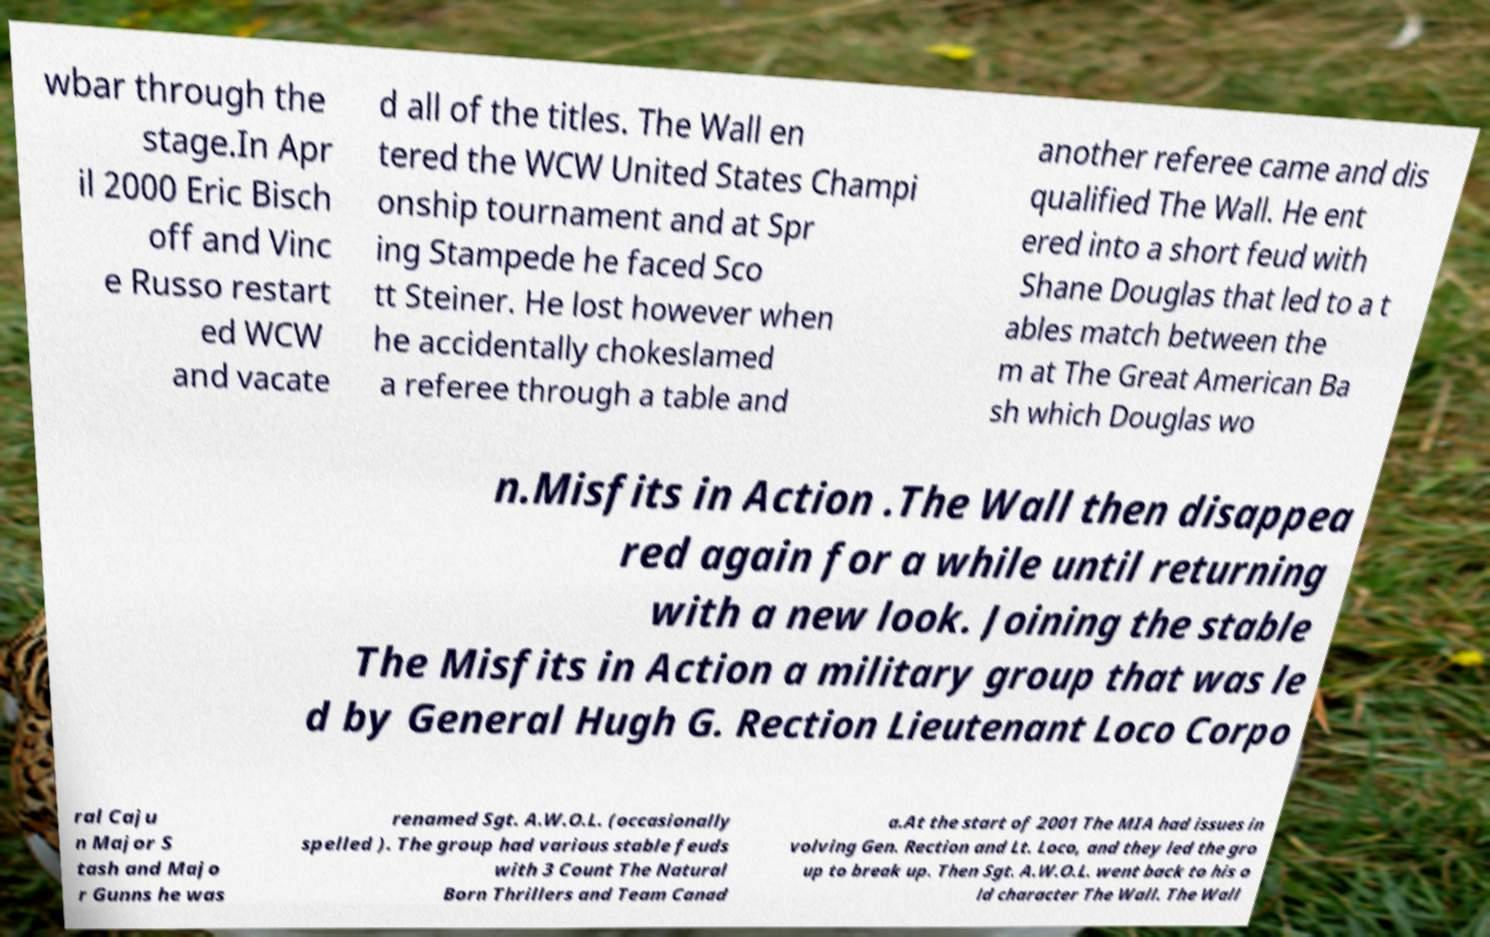Could you extract and type out the text from this image? wbar through the stage.In Apr il 2000 Eric Bisch off and Vinc e Russo restart ed WCW and vacate d all of the titles. The Wall en tered the WCW United States Champi onship tournament and at Spr ing Stampede he faced Sco tt Steiner. He lost however when he accidentally chokeslamed a referee through a table and another referee came and dis qualified The Wall. He ent ered into a short feud with Shane Douglas that led to a t ables match between the m at The Great American Ba sh which Douglas wo n.Misfits in Action .The Wall then disappea red again for a while until returning with a new look. Joining the stable The Misfits in Action a military group that was le d by General Hugh G. Rection Lieutenant Loco Corpo ral Caju n Major S tash and Majo r Gunns he was renamed Sgt. A.W.O.L. (occasionally spelled ). The group had various stable feuds with 3 Count The Natural Born Thrillers and Team Canad a.At the start of 2001 The MIA had issues in volving Gen. Rection and Lt. Loco, and they led the gro up to break up. Then Sgt. A.W.O.L. went back to his o ld character The Wall. The Wall 